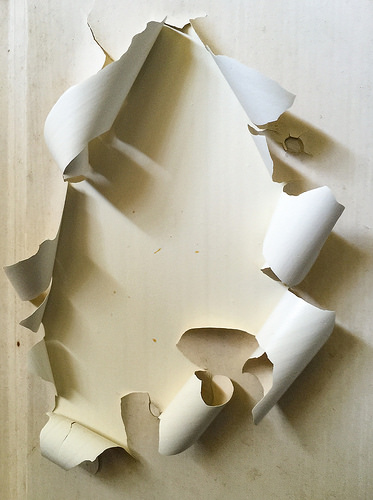<image>
Is the wall behind the wallpaper? No. The wall is not behind the wallpaper. From this viewpoint, the wall appears to be positioned elsewhere in the scene. 